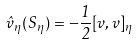Convert formula to latex. <formula><loc_0><loc_0><loc_500><loc_500>\hat { v } _ { \eta } ( S _ { \eta } ) = - \frac { 1 } { 2 } [ v , v ] _ { \eta }</formula> 